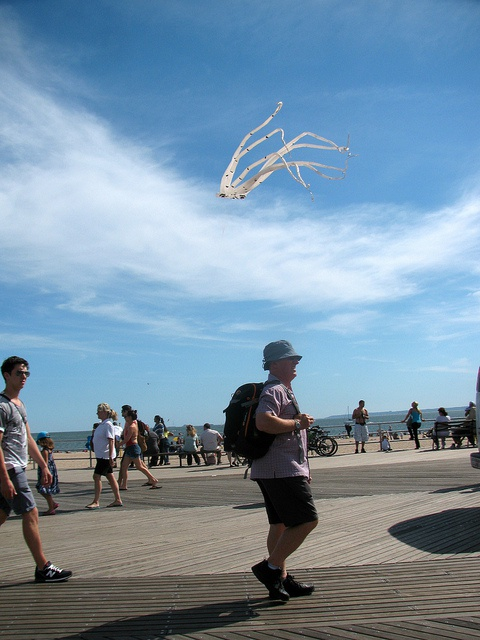Describe the objects in this image and their specific colors. I can see people in blue, black, gray, and darkgray tones, people in blue, black, gray, maroon, and darkgray tones, kite in blue, darkgray, lightgray, and gray tones, backpack in blue, black, maroon, gray, and darkblue tones, and people in blue, black, gray, maroon, and darkgray tones in this image. 